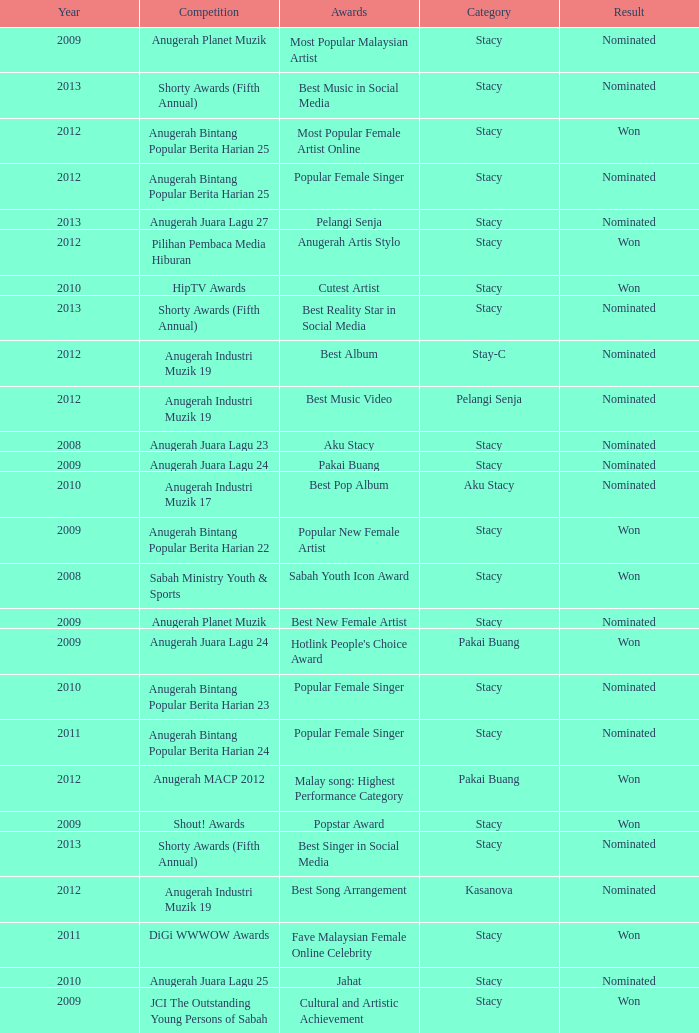What was the result in the year greaters than 2008 with an award of Jahat and had a category of Stacy? Nominated. 